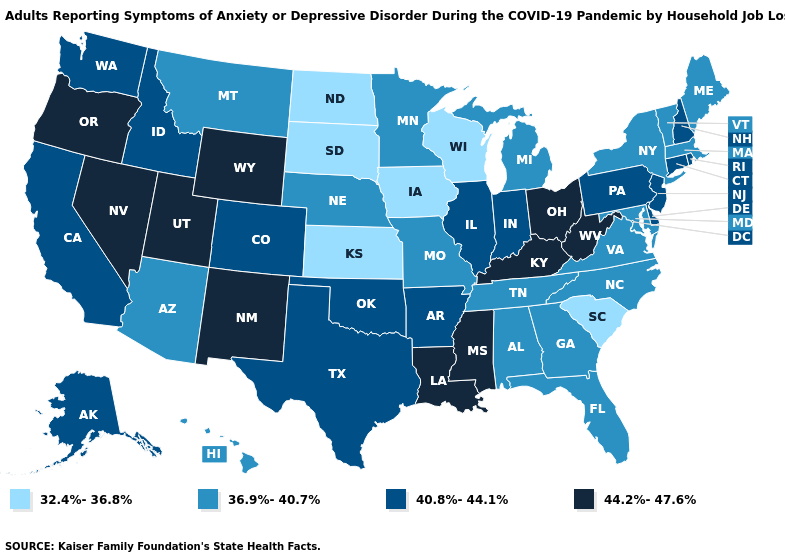Does Oregon have a higher value than Nevada?
Short answer required. No. Among the states that border New Jersey , does New York have the highest value?
Write a very short answer. No. Among the states that border Kansas , does Colorado have the lowest value?
Answer briefly. No. Does Ohio have the same value as Nevada?
Answer briefly. Yes. Among the states that border Wyoming , does Utah have the lowest value?
Give a very brief answer. No. What is the lowest value in states that border South Carolina?
Write a very short answer. 36.9%-40.7%. Does New Mexico have the highest value in the USA?
Keep it brief. Yes. How many symbols are there in the legend?
Write a very short answer. 4. Among the states that border North Dakota , does South Dakota have the lowest value?
Concise answer only. Yes. Name the states that have a value in the range 40.8%-44.1%?
Concise answer only. Alaska, Arkansas, California, Colorado, Connecticut, Delaware, Idaho, Illinois, Indiana, New Hampshire, New Jersey, Oklahoma, Pennsylvania, Rhode Island, Texas, Washington. What is the lowest value in states that border Nevada?
Keep it brief. 36.9%-40.7%. Does Kentucky have a higher value than Idaho?
Keep it brief. Yes. Which states have the lowest value in the South?
Keep it brief. South Carolina. Which states hav the highest value in the Northeast?
Answer briefly. Connecticut, New Hampshire, New Jersey, Pennsylvania, Rhode Island. What is the lowest value in the USA?
Quick response, please. 32.4%-36.8%. 